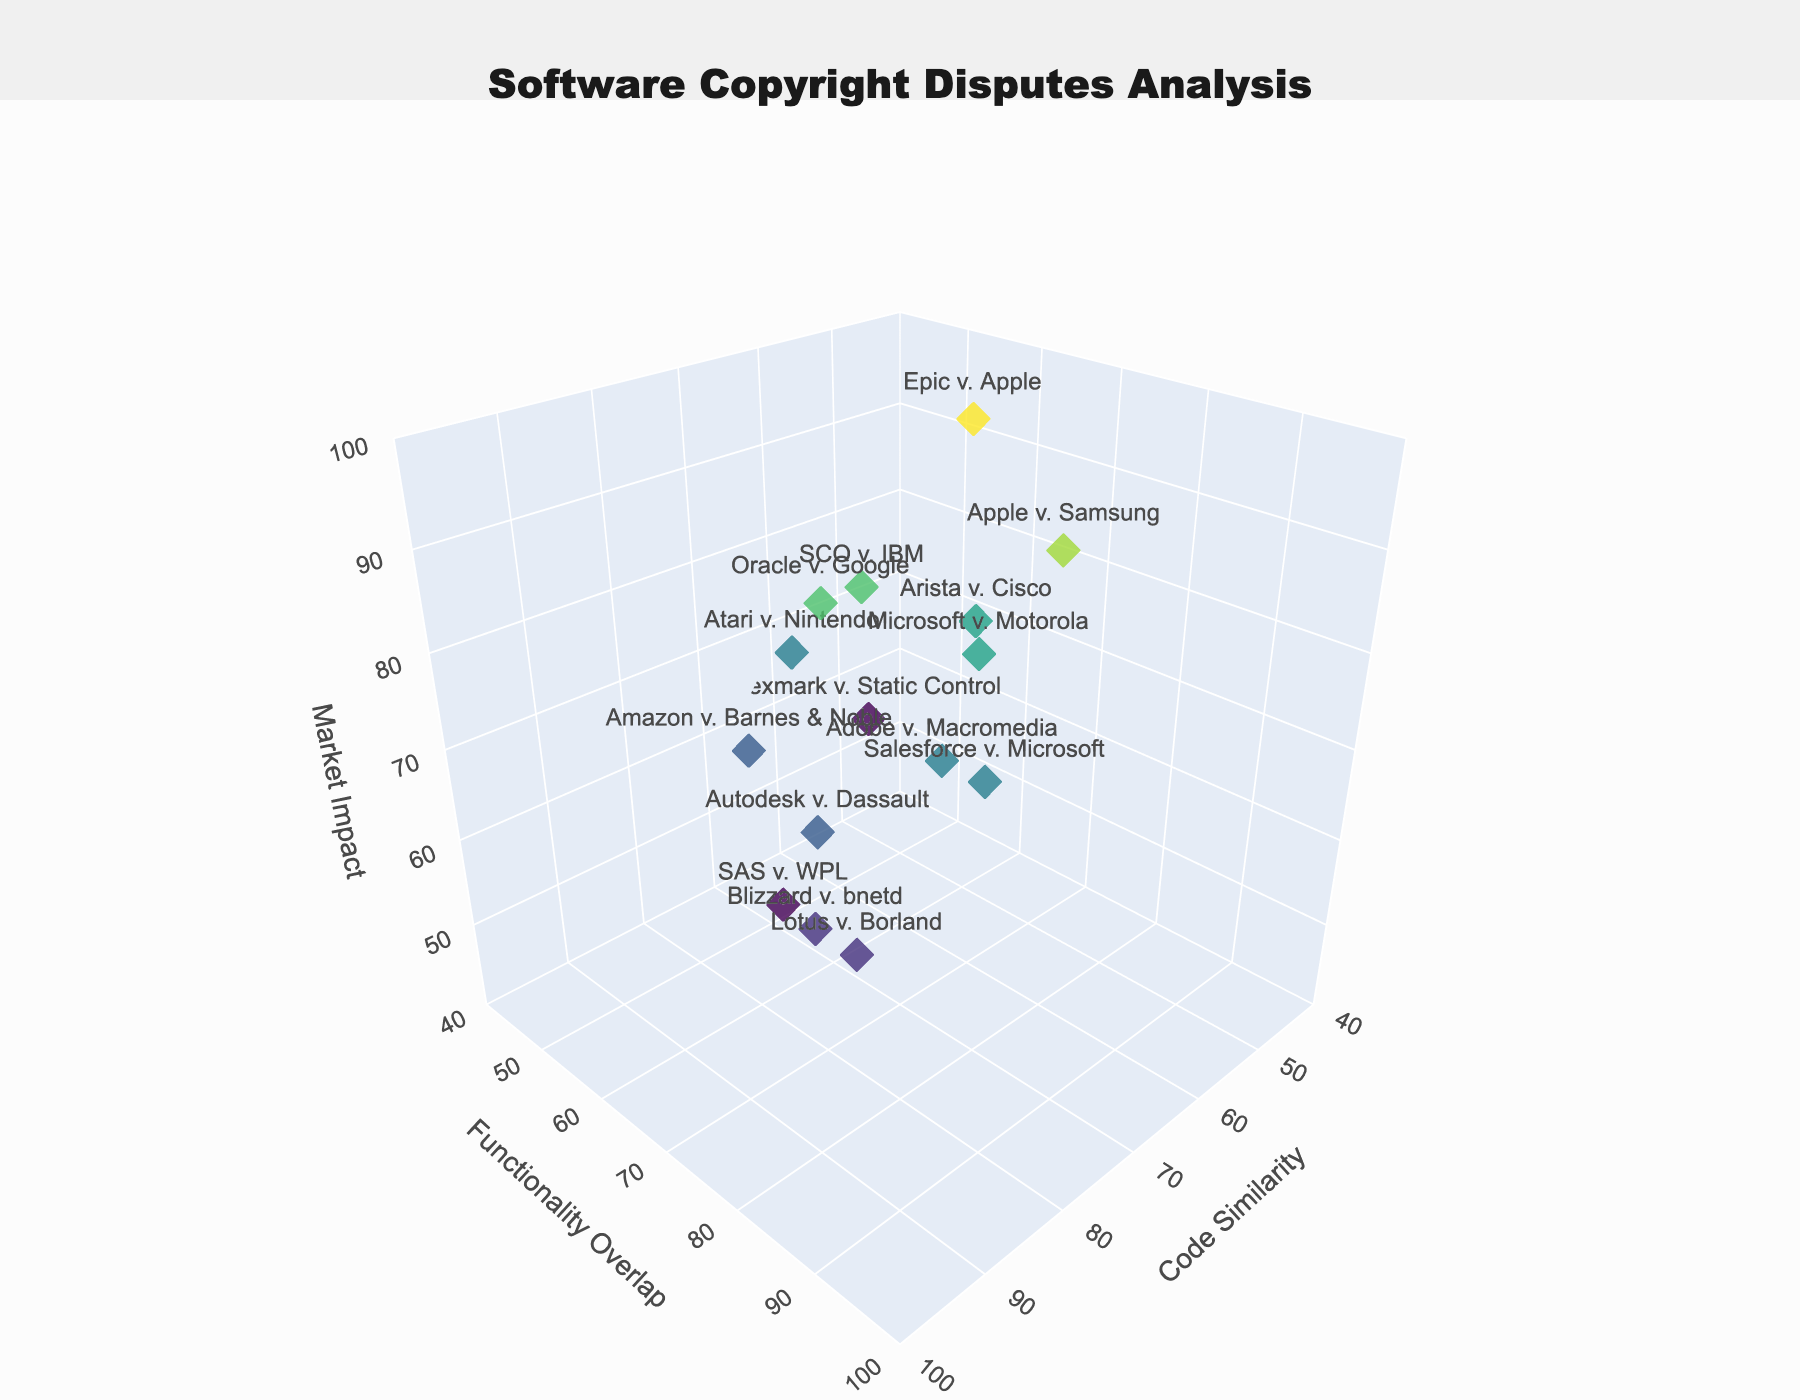Which case has the highest code similarity? By examining the plot, look for the point on the 'Code Similarity' axis with the highest value and check the associated text label.
Answer: Lotus v. Borland How many cases have a market impact greater than 80? Count how many points on the 'Market Impact' axis are above the value of 80.
Answer: Four What are the title and axis labels of the plot? The title is displayed at the top, and the axis labels are visible on each axis.
Answer: Title: Software Copyright Disputes Analysis; Axes: Code Similarity, Functionality Overlap, Market Impact Which case has the lowest market impact and what is its value? Identify the lowest point on the 'Market Impact' axis and read the associated text label and its value.
Answer: Lexmark v. Static Control, 60 What is the average code similarity of the cases Apple v. Samsung, Autodesk v. Dassault, and Arista v. Cisco? Sum the code similarity of the three cases and divide by 3: (60 + 85 + 60) / 3 = 68.33.
Answer: 68.33 Which case has the highest functionality overlap combined with a market impact above 90? Look for the point with the highest 'Functionality Overlap' value where the 'Market Impact' is also above 90, and identify the case.
Answer: Epic v. Apple Compare the market impact of Oracle v. Google and Microsoft v. Motorola. Which is higher, and by how much? Check the market impact values of both cases and calculate the difference: 85 (Oracle v. Google) - 80 (Microsoft v. Motorola) = 5.
Answer: Oracle v. Google, by 5 Are there any cases with both code similarity and functionality overlap above 85? Examine the plot for points that exceed 85 on both the 'Code Similarity' and 'Functionality Overlap' axes.
Answer: Yes, Lotus v. Borland What is the combined value of code similarity and functionality overlap for Amazon v. Barnes & Noble? Add the two values together: 80 (Code Similarity) + 60 (Functionality Overlap) = 140.
Answer: 140 What cases have a market impact between 70 and 80, and what are their functionality overlaps? Identify points within the 70 to 80 range on the 'Market Impact' axis and list their 'Functionality Overlap' values.
Answer: Amazon v. Barnes & Noble: 60; Autodesk v. Dassault: 75; Adobe v. Macromedia: 80; Salesforce v. Microsoft: 85 